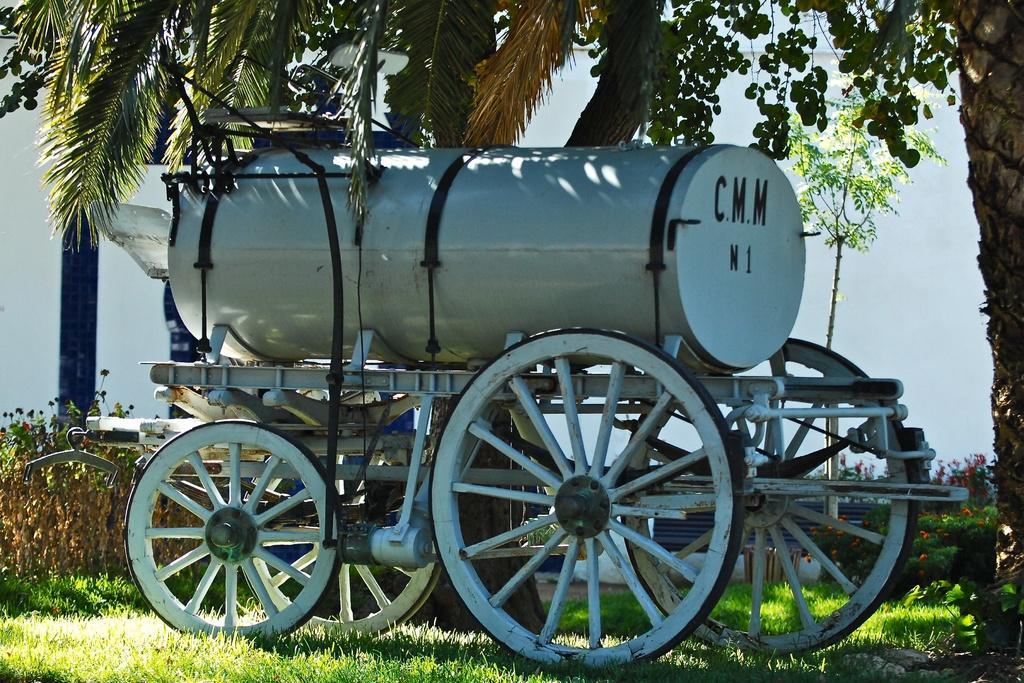Can you describe this image briefly? In the picture I can see a travelling car and there is a tank on the cart. I can see the green grass at the bottom of the image. I can see the flowering plants on the right side. In the image I can see the trees. 